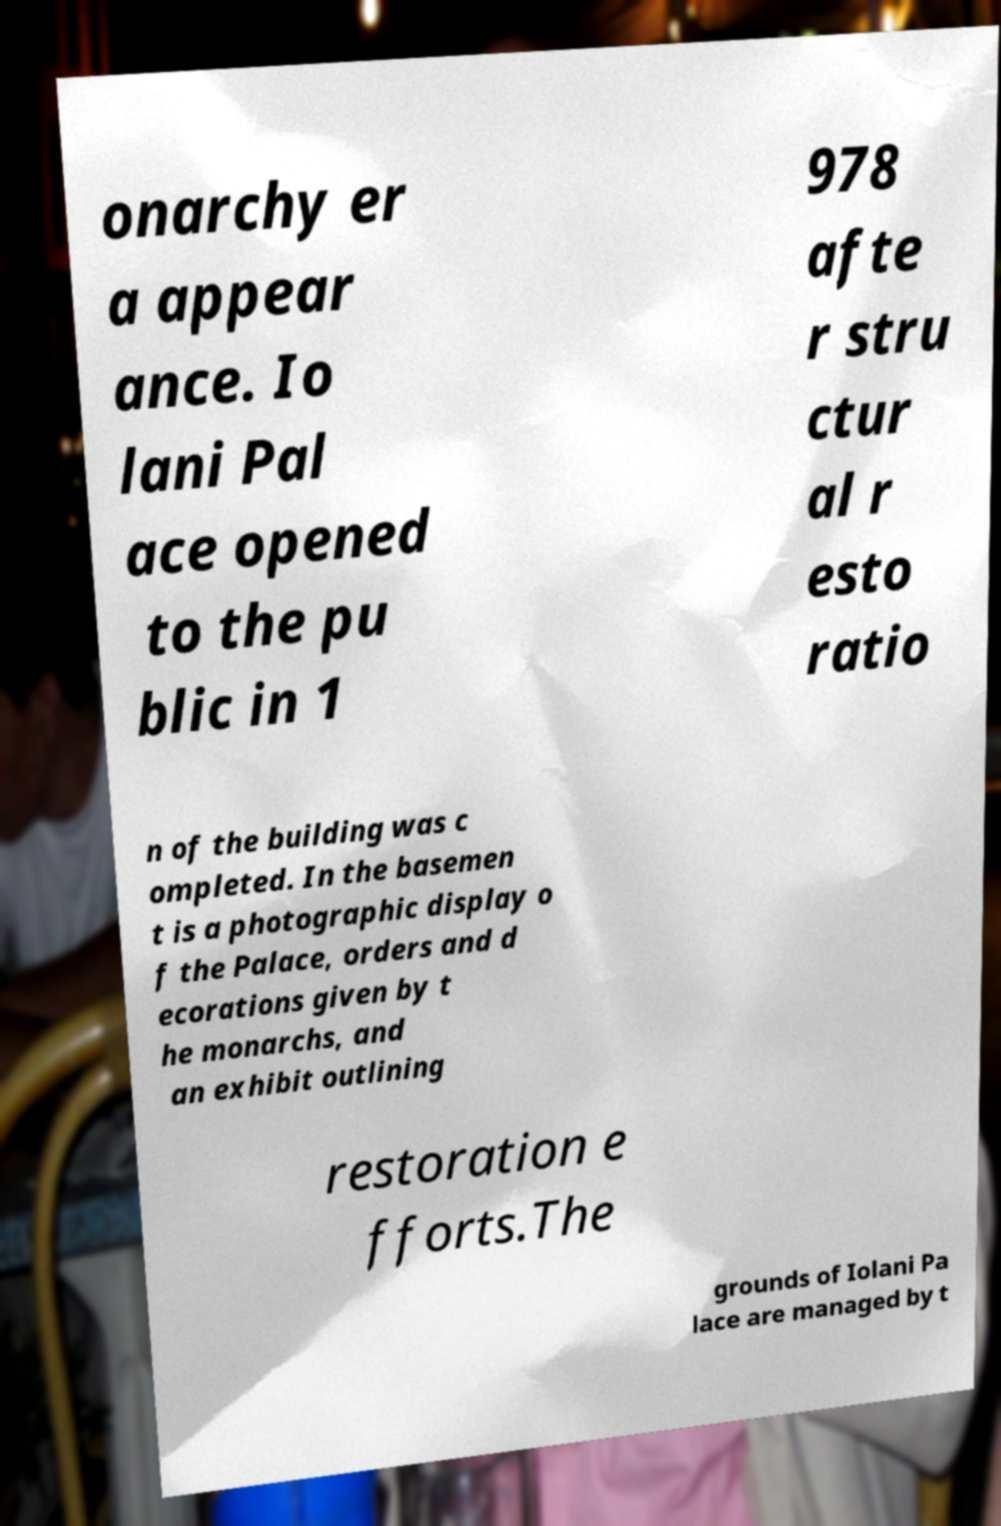I need the written content from this picture converted into text. Can you do that? onarchy er a appear ance. Io lani Pal ace opened to the pu blic in 1 978 afte r stru ctur al r esto ratio n of the building was c ompleted. In the basemen t is a photographic display o f the Palace, orders and d ecorations given by t he monarchs, and an exhibit outlining restoration e fforts.The grounds of Iolani Pa lace are managed by t 